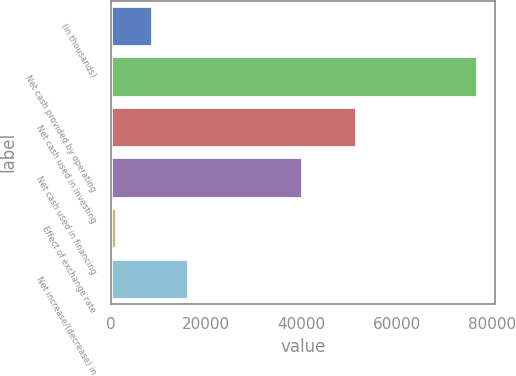<chart> <loc_0><loc_0><loc_500><loc_500><bar_chart><fcel>(in thousands)<fcel>Net cash provided by operating<fcel>Net cash used in investing<fcel>Net cash used in financing<fcel>Effect of exchange rate<fcel>Net increase/(decrease) in<nl><fcel>8677.6<fcel>76750<fcel>51387<fcel>40149<fcel>1114<fcel>16241.2<nl></chart> 